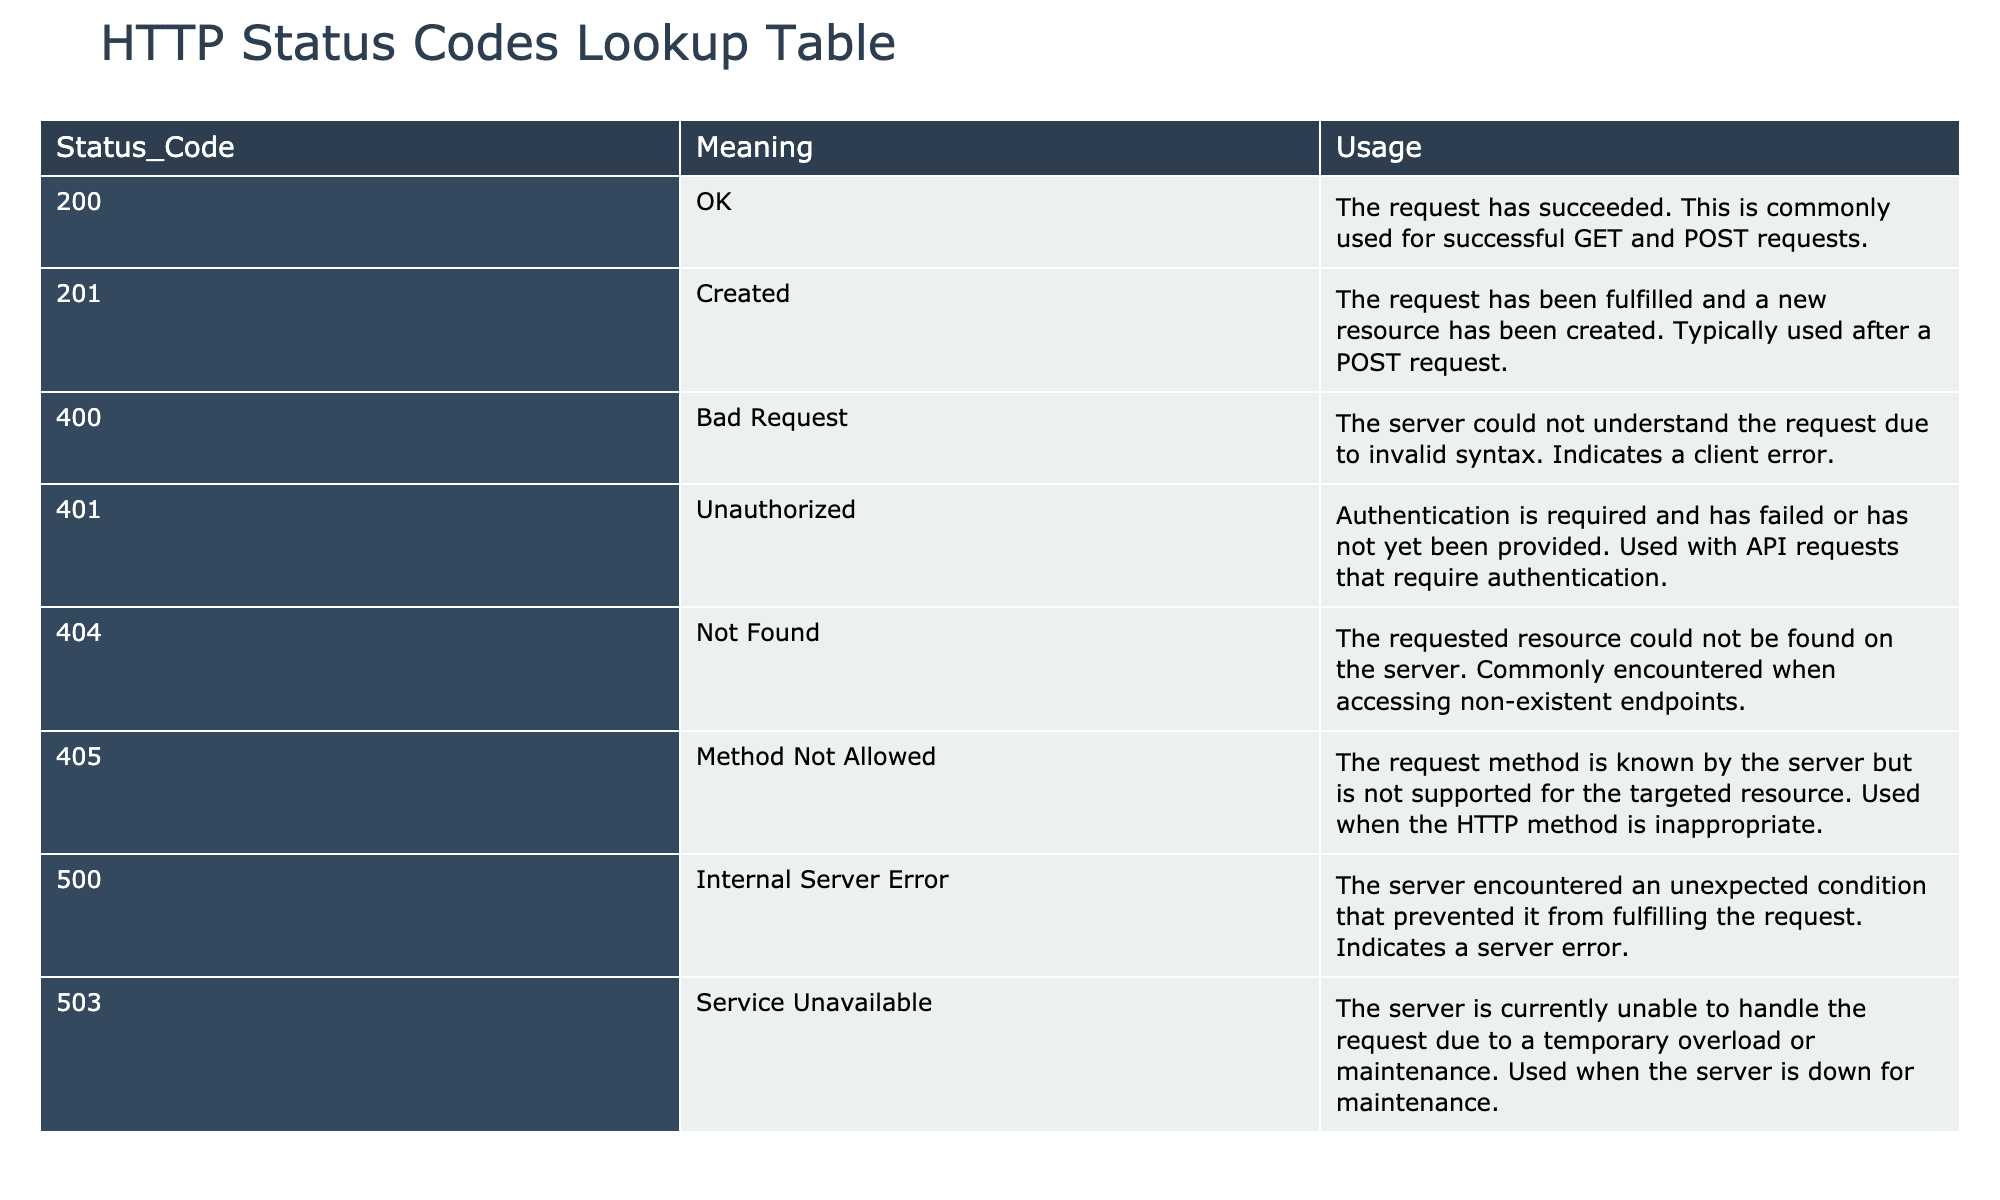What does the status code 200 mean? According to the table, the status code 200 means "OK". This indicates that the request has succeeded.
Answer: OK Which status code should you expect when a new resource has been created? The table indicates that the status code for a successfully created resource is 201, with the meaning "Created".
Answer: 201 Is a 404 status code a client error? Yes, the table shows that a 404 status code means "Not Found" and indicates that the requested resource could not be found on the server, which qualifies as a client error.
Answer: Yes What is the difference between the 400 and 401 status codes? The 400 status code means "Bad Request" and indicates a client error due to syntax issues. In contrast, the 401 status code means "Unauthorized" and requires authentication. This is handled by examining their descriptions in the table.
Answer: Bad Request is syntax error; Unauthorized requires authentication Which status code would you use to indicate that a server is currently unable to handle requests? The status code for when the server is temporarily unavailable is 503, as indicated in the table where the usage states it's due to overload or maintenance.
Answer: 503 What is the usage of the status code 405? The table describes the usage of status code 405 as "Method Not Allowed", indicating that the request method is known to the server but not supported for the specific resource.
Answer: Method Not Allowed indicates unsupported request method If a request returns a 500 status code, what can be inferred about the server? A 500 status code means "Internal Server Error", which suggests that the server encountered an unexpected condition preventing it from fulfilling the request. The table references this as a server error situation.
Answer: The server encountered an unexpected error Are status codes in the 400 range considered successful responses? No, the table indicates that status codes in the 400 range, such as 400 (Bad Request) and 401 (Unauthorized), are indicative of client errors, not successful responses.
Answer: No Which status codes indicate a successful request, and how many are there? The table shows that both 200 (OK) and 201 (Created) are success indicators, which totals to two status codes. This requires referencing the meanings and categorizing them as successful responses.
Answer: Two status codes: 200 and 201 